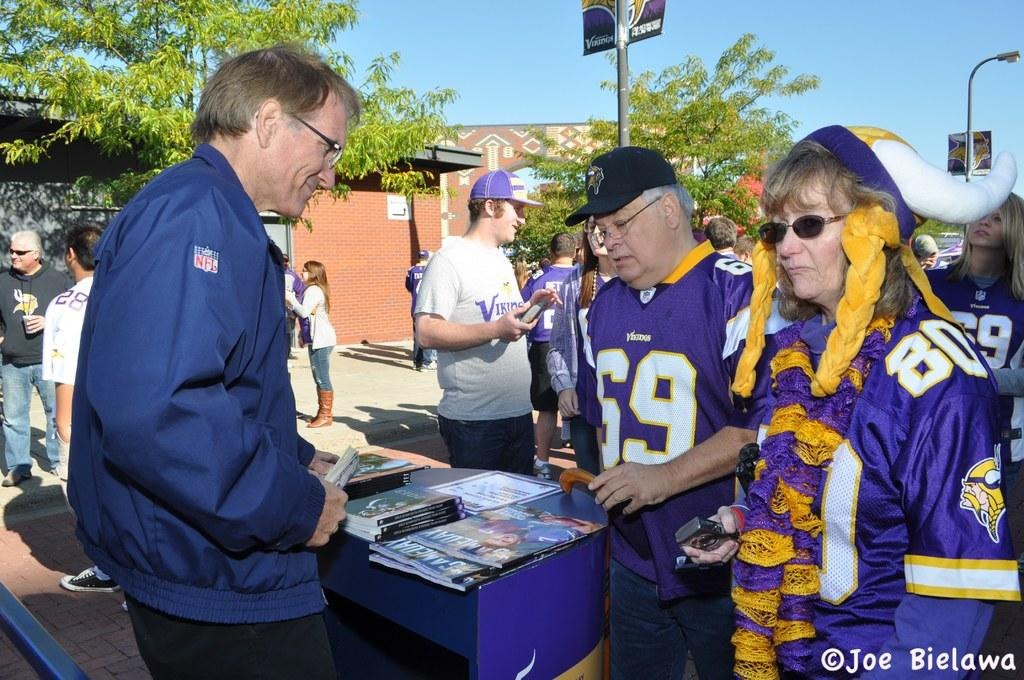<image>
Offer a succinct explanation of the picture presented. A game day celebration with an older couple in Vicking jerseys numbered 69 and 80. 